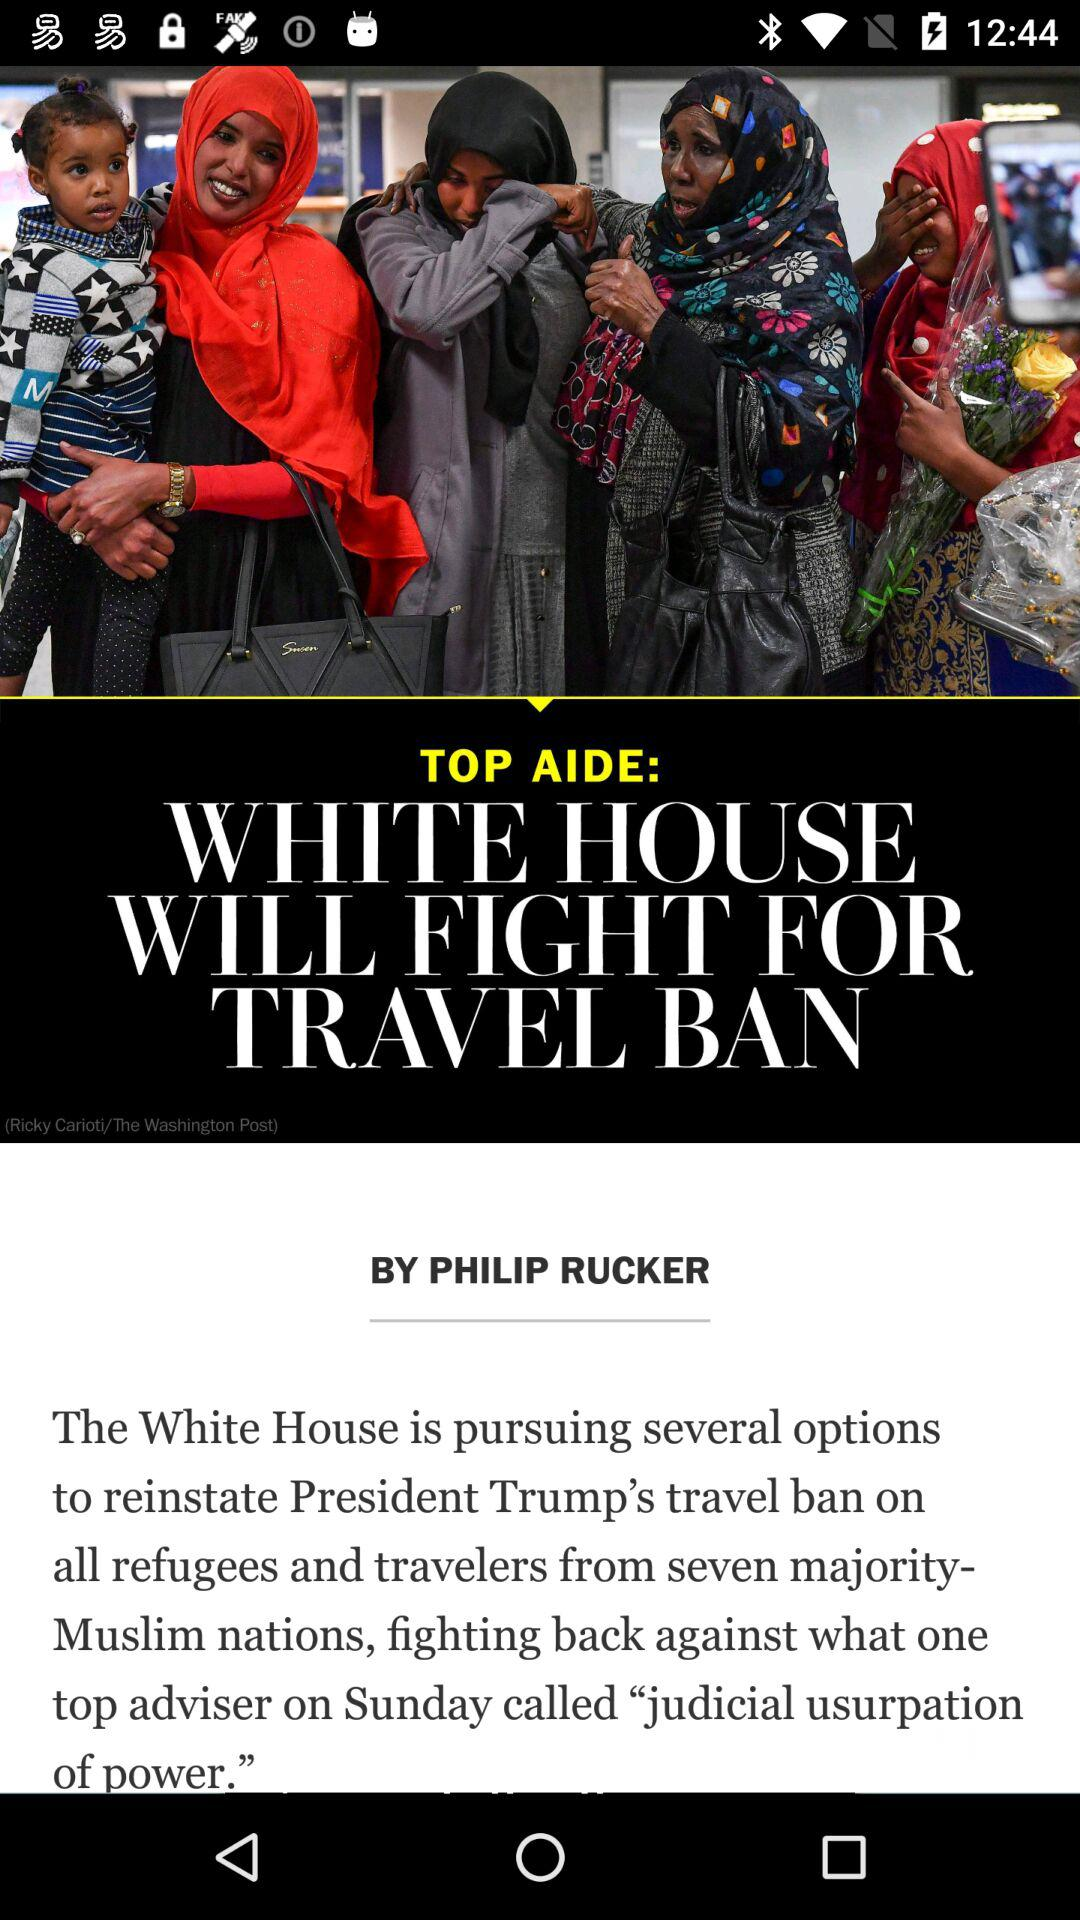Who is the author? The author is Philip Rucker. 